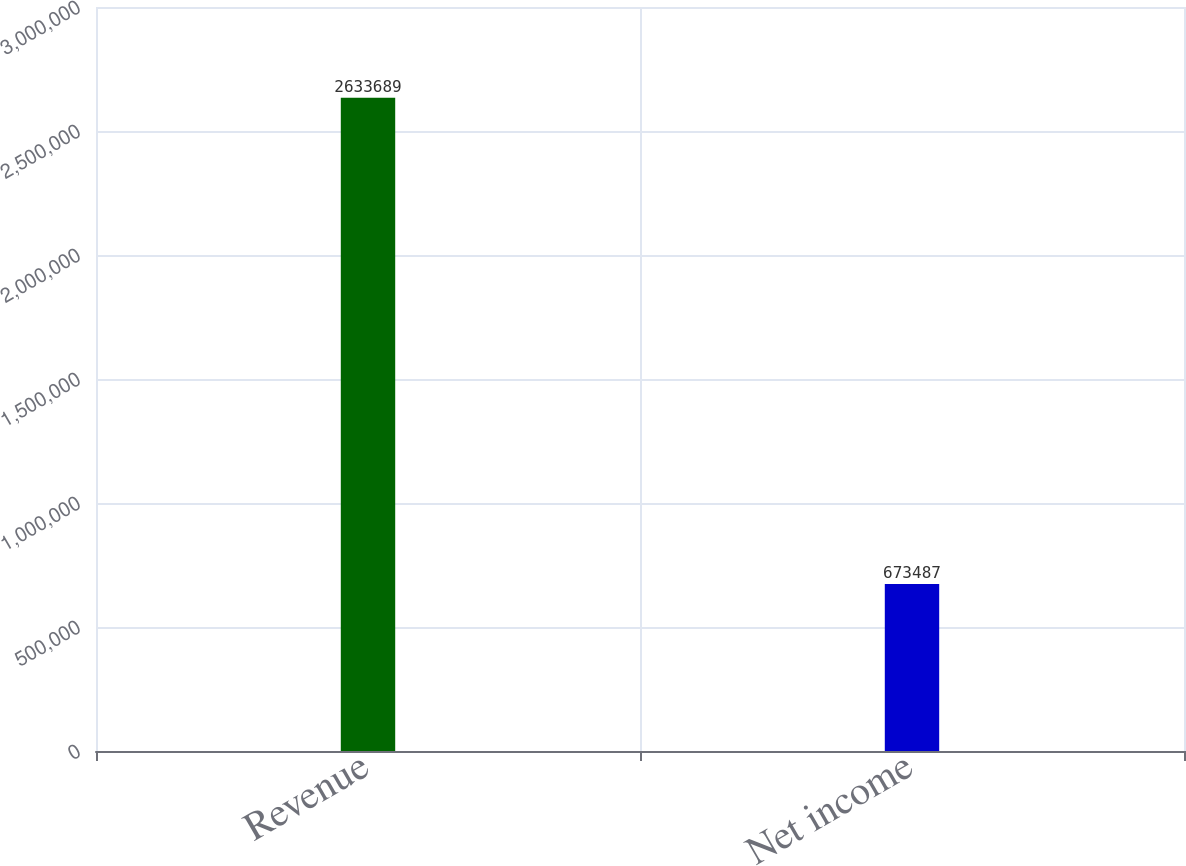Convert chart to OTSL. <chart><loc_0><loc_0><loc_500><loc_500><bar_chart><fcel>Revenue<fcel>Net income<nl><fcel>2.63369e+06<fcel>673487<nl></chart> 